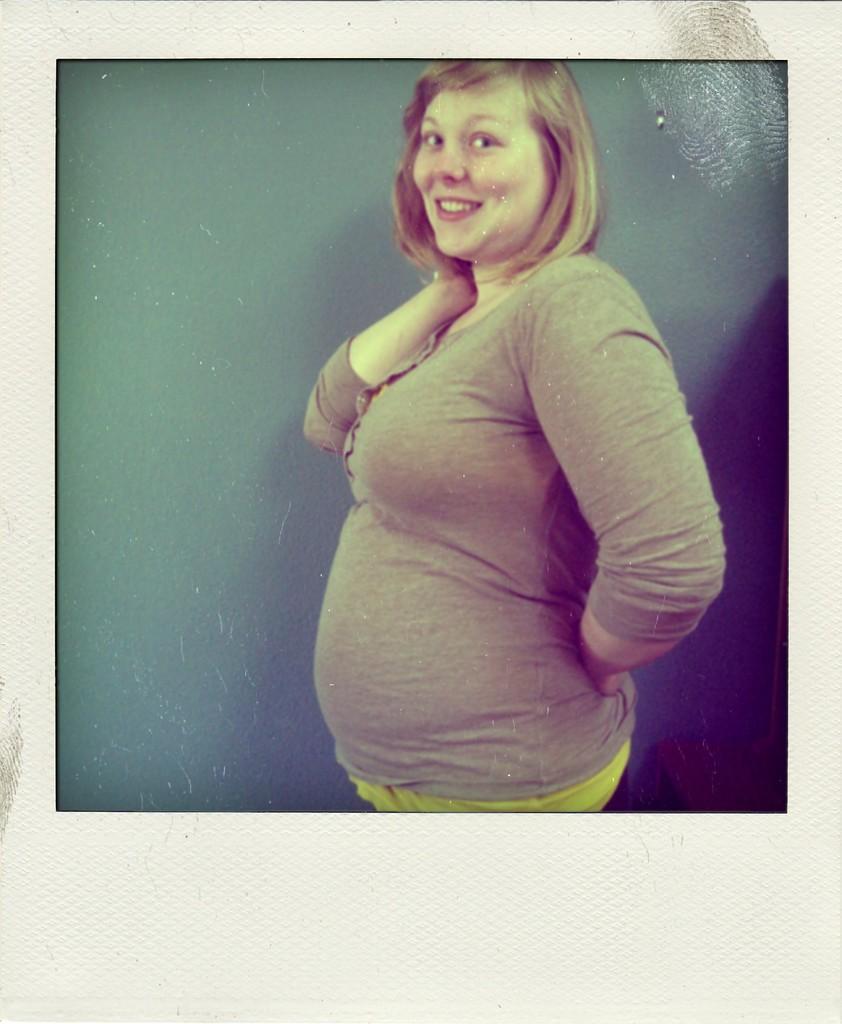How would you summarize this image in a sentence or two? In this image we can see the picture of a woman standing. 